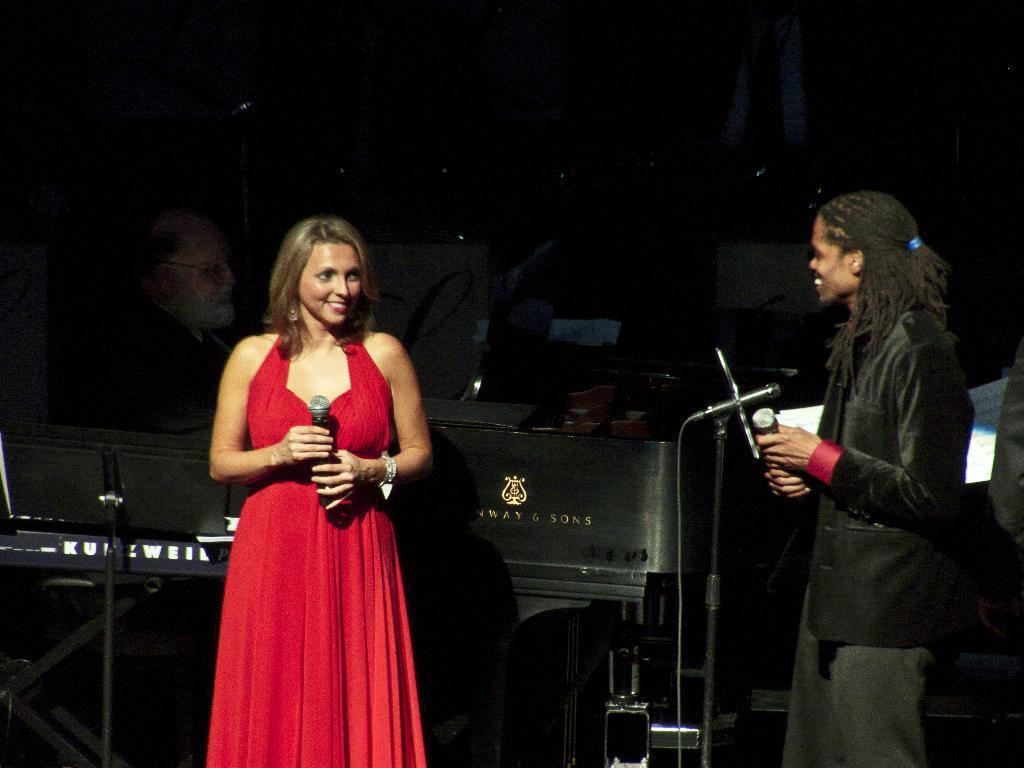In one or two sentences, can you explain what this image depicts? In this image I can see there are two people standing one girl wearing a red dress and holding a mike and one on the right side wearing a black dress 